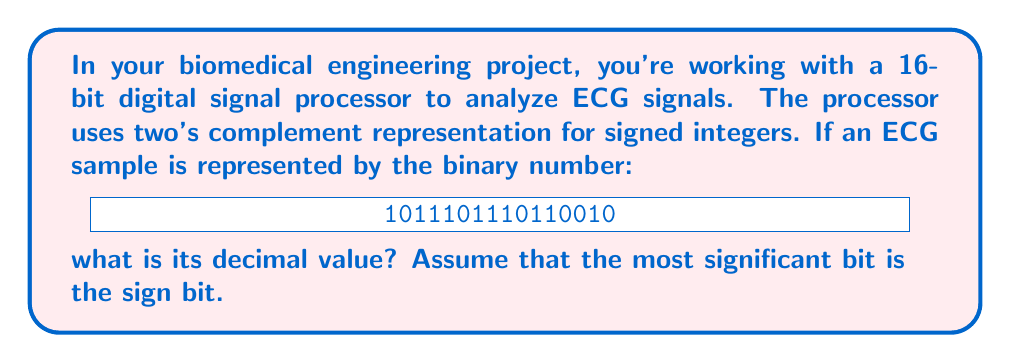Solve this math problem. Let's approach this step-by-step:

1) First, we identify that the number is negative because the most significant bit (leftmost) is 1.

2) To find the decimal value of a negative number in two's complement, we need to:
   a) Invert all the bits
   b) Add 1 to the result
   c) Calculate the decimal value
   d) Add a negative sign

3) Let's invert all the bits:
   Original: 1011101110110010
   Inverted: 0100010001001101

4) Now, add 1 to the inverted number:
   0100010001001101
   +               1
   ----------------
   0100010001001110

5) Calculate the decimal value of this positive binary number:

   $$(0 \times 2^{15}) + (1 \times 2^{14}) + (0 \times 2^{13}) + ... + (1 \times 2^1) + (0 \times 2^0)$$

   $$= 2^{14} + 2^{10} + 2^9 + 2^3 + 2^2 + 2^1$$
   $$= 16384 + 1024 + 512 + 8 + 4 + 2$$
   $$= 17934$$

6) Finally, add the negative sign:
   $$-17934$$

This is the decimal value of the original two's complement number.
Answer: $-17934$ 